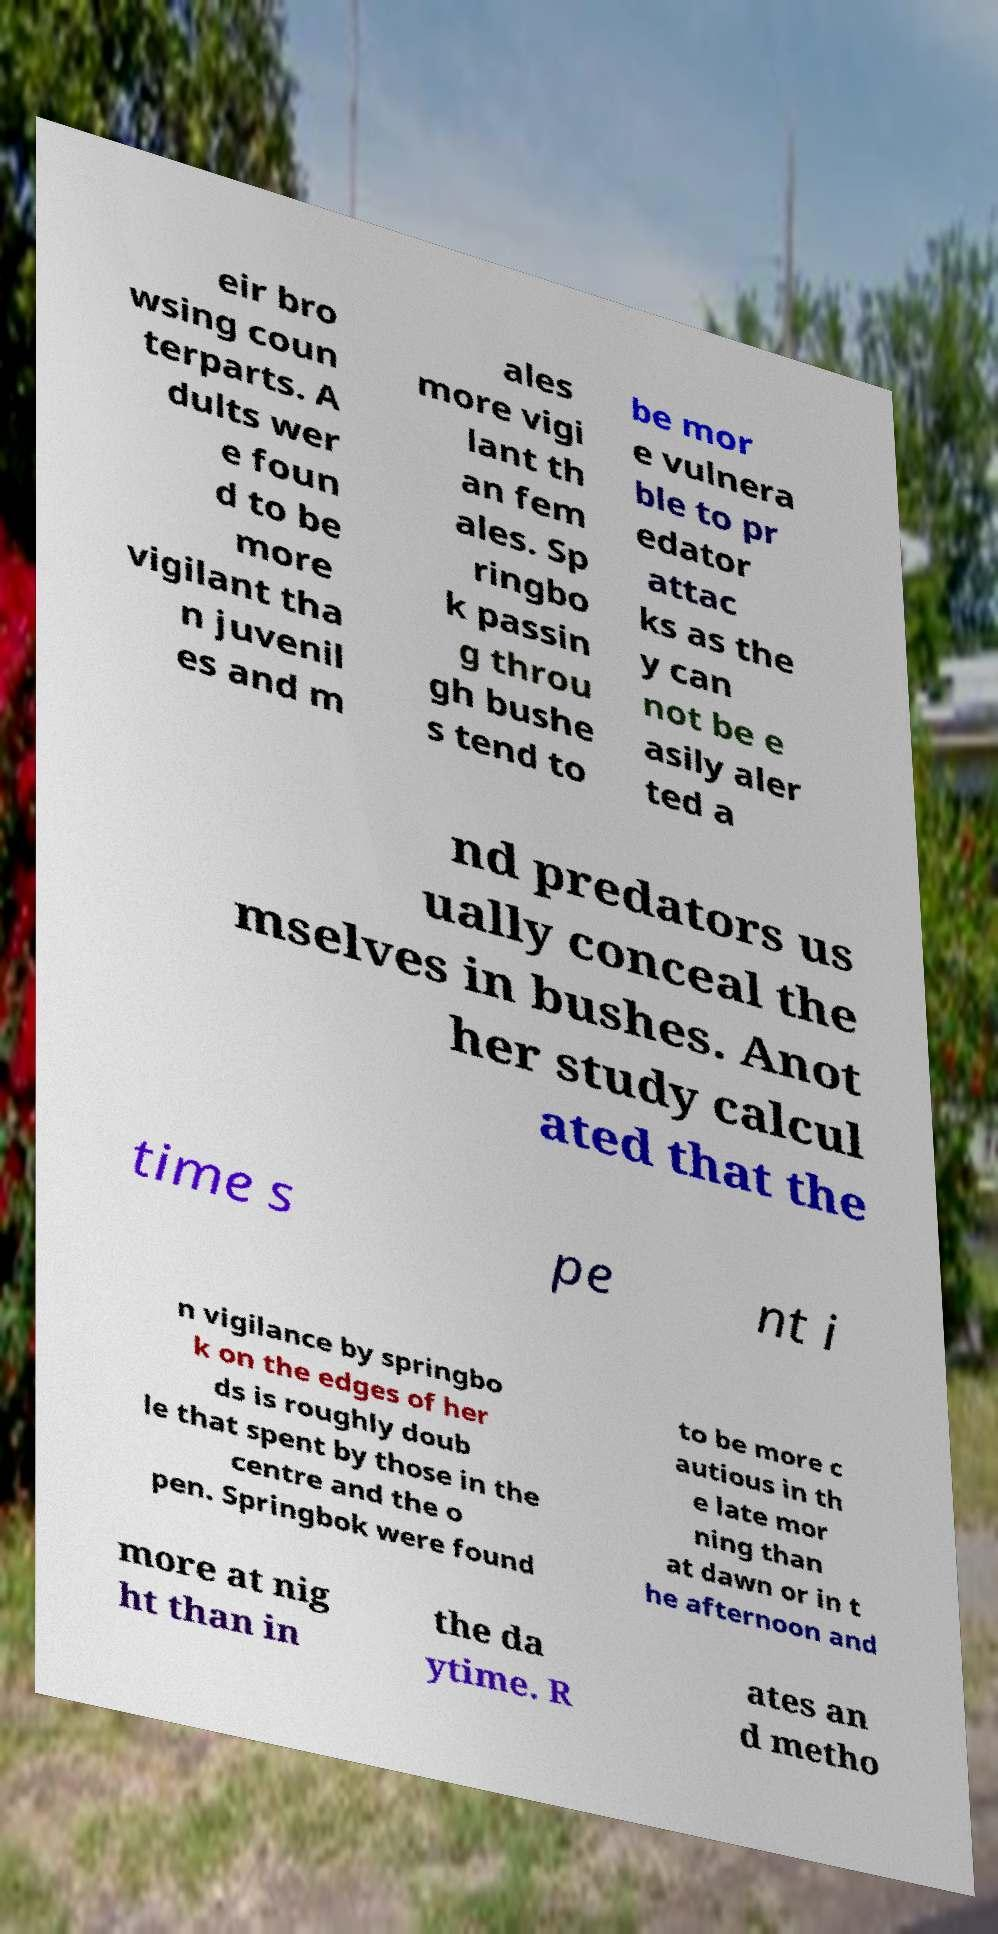Please read and relay the text visible in this image. What does it say? eir bro wsing coun terparts. A dults wer e foun d to be more vigilant tha n juvenil es and m ales more vigi lant th an fem ales. Sp ringbo k passin g throu gh bushe s tend to be mor e vulnera ble to pr edator attac ks as the y can not be e asily aler ted a nd predators us ually conceal the mselves in bushes. Anot her study calcul ated that the time s pe nt i n vigilance by springbo k on the edges of her ds is roughly doub le that spent by those in the centre and the o pen. Springbok were found to be more c autious in th e late mor ning than at dawn or in t he afternoon and more at nig ht than in the da ytime. R ates an d metho 